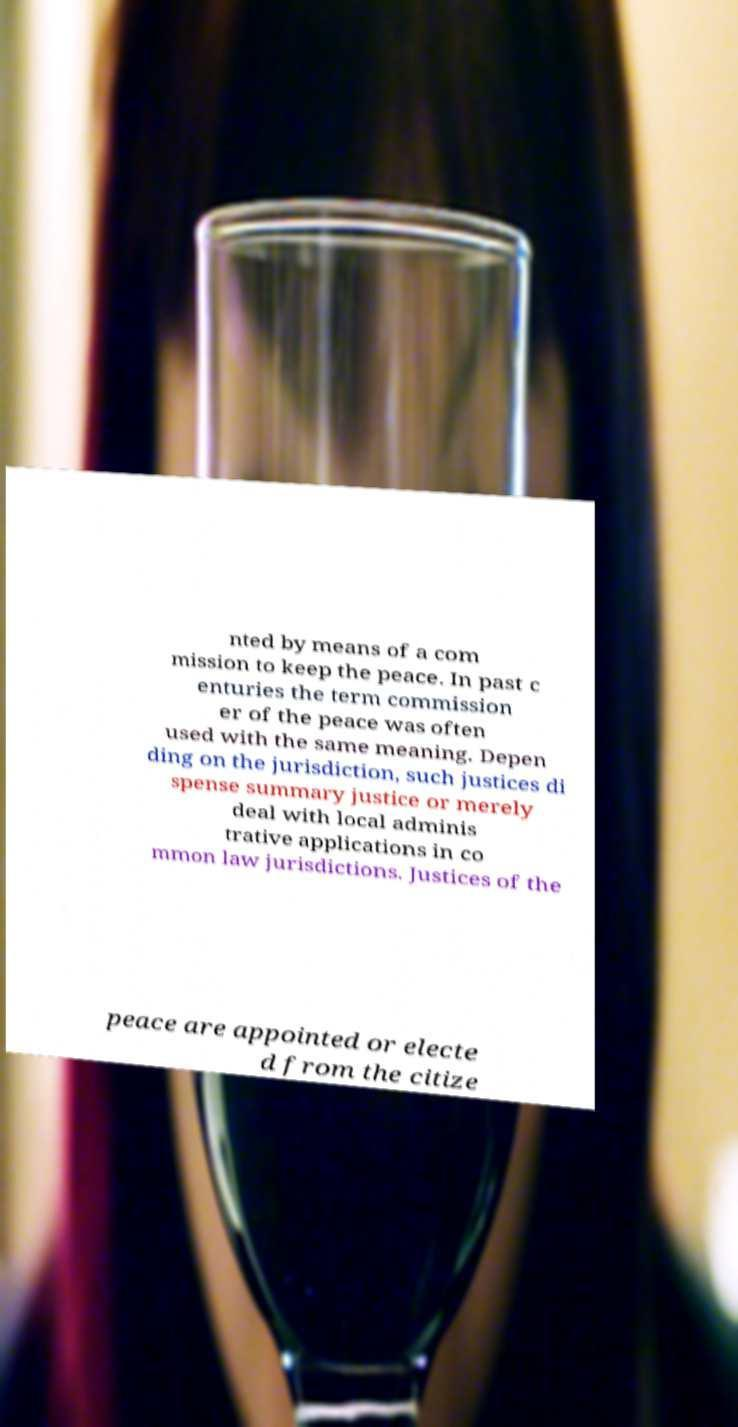For documentation purposes, I need the text within this image transcribed. Could you provide that? nted by means of a com mission to keep the peace. In past c enturies the term commission er of the peace was often used with the same meaning. Depen ding on the jurisdiction, such justices di spense summary justice or merely deal with local adminis trative applications in co mmon law jurisdictions. Justices of the peace are appointed or electe d from the citize 